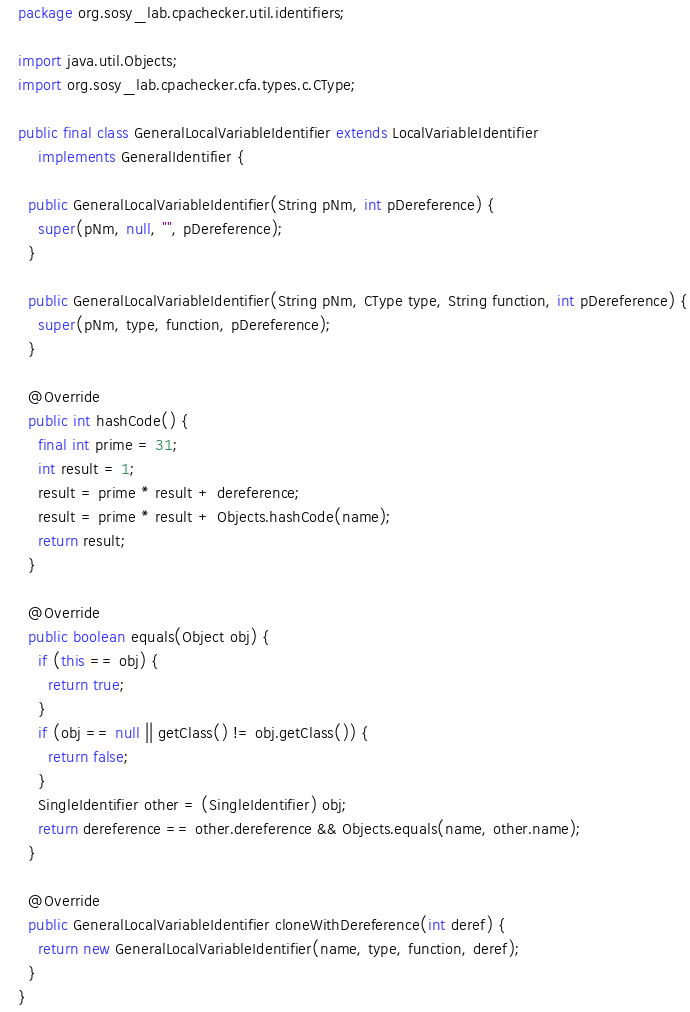<code> <loc_0><loc_0><loc_500><loc_500><_Java_>package org.sosy_lab.cpachecker.util.identifiers;

import java.util.Objects;
import org.sosy_lab.cpachecker.cfa.types.c.CType;

public final class GeneralLocalVariableIdentifier extends LocalVariableIdentifier
    implements GeneralIdentifier {

  public GeneralLocalVariableIdentifier(String pNm, int pDereference) {
    super(pNm, null, "", pDereference);
  }

  public GeneralLocalVariableIdentifier(String pNm, CType type, String function, int pDereference) {
    super(pNm, type, function, pDereference);
  }

  @Override
  public int hashCode() {
    final int prime = 31;
    int result = 1;
    result = prime * result + dereference;
    result = prime * result + Objects.hashCode(name);
    return result;
  }

  @Override
  public boolean equals(Object obj) {
    if (this == obj) {
      return true;
    }
    if (obj == null || getClass() != obj.getClass()) {
      return false;
    }
    SingleIdentifier other = (SingleIdentifier) obj;
    return dereference == other.dereference && Objects.equals(name, other.name);
  }

  @Override
  public GeneralLocalVariableIdentifier cloneWithDereference(int deref) {
    return new GeneralLocalVariableIdentifier(name, type, function, deref);
  }
}
</code> 